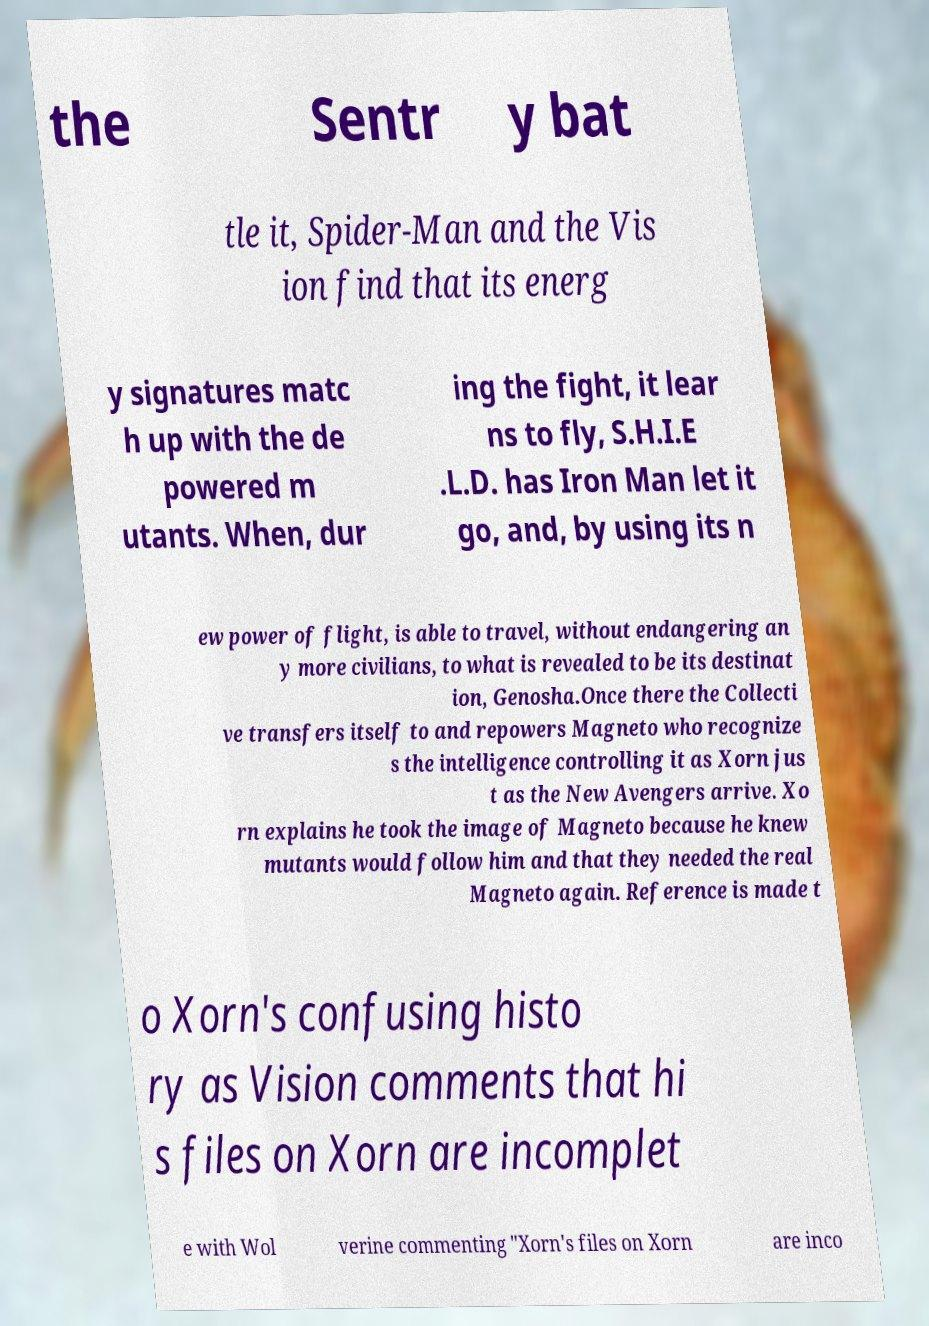Please identify and transcribe the text found in this image. the Sentr y bat tle it, Spider-Man and the Vis ion find that its energ y signatures matc h up with the de powered m utants. When, dur ing the fight, it lear ns to fly, S.H.I.E .L.D. has Iron Man let it go, and, by using its n ew power of flight, is able to travel, without endangering an y more civilians, to what is revealed to be its destinat ion, Genosha.Once there the Collecti ve transfers itself to and repowers Magneto who recognize s the intelligence controlling it as Xorn jus t as the New Avengers arrive. Xo rn explains he took the image of Magneto because he knew mutants would follow him and that they needed the real Magneto again. Reference is made t o Xorn's confusing histo ry as Vision comments that hi s files on Xorn are incomplet e with Wol verine commenting "Xorn's files on Xorn are inco 